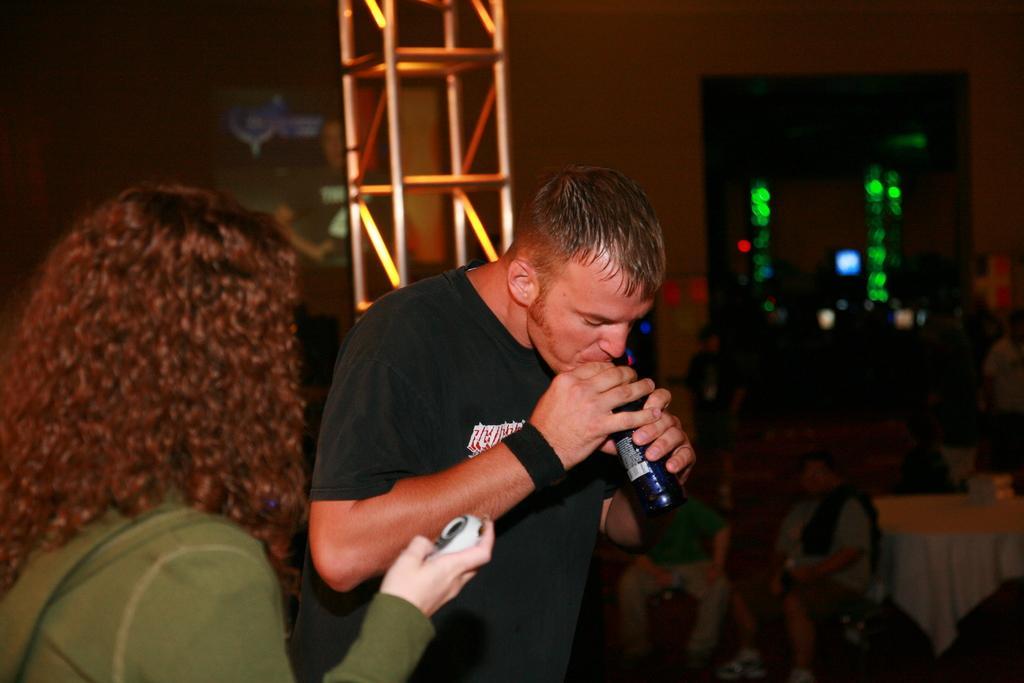In one or two sentences, can you explain what this image depicts? In this picture we can see a man, woman and a woman is holding an object and a man is holding a bottle and in the background we can see few people, wall, table and some objects. 